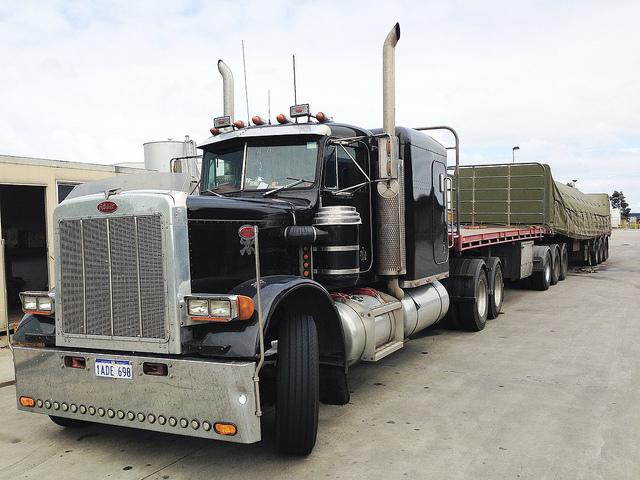How many wheels does this truck have?
Quick response, please. 18. Is the truck polluting?
Write a very short answer. Yes. How many horns does the truck have on each side?
Write a very short answer. 2. Is this truck pulling a trailer?
Keep it brief. Yes. 